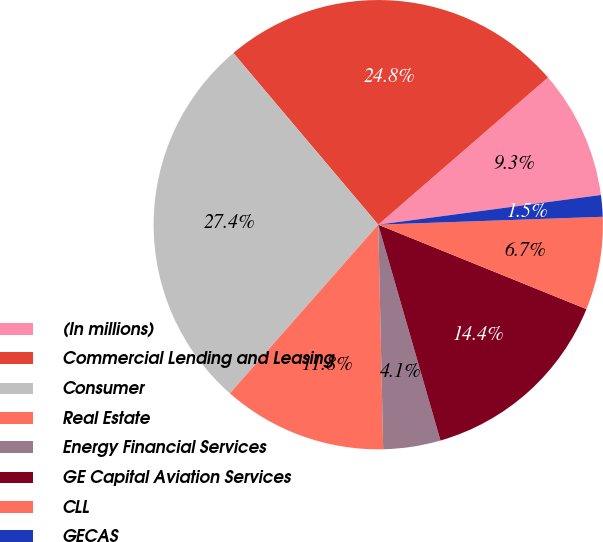Convert chart. <chart><loc_0><loc_0><loc_500><loc_500><pie_chart><fcel>(In millions)<fcel>Commercial Lending and Leasing<fcel>Consumer<fcel>Real Estate<fcel>Energy Financial Services<fcel>GE Capital Aviation Services<fcel>CLL<fcel>GECAS<nl><fcel>9.26%<fcel>24.79%<fcel>27.36%<fcel>11.83%<fcel>4.12%<fcel>14.4%<fcel>6.69%<fcel>1.55%<nl></chart> 